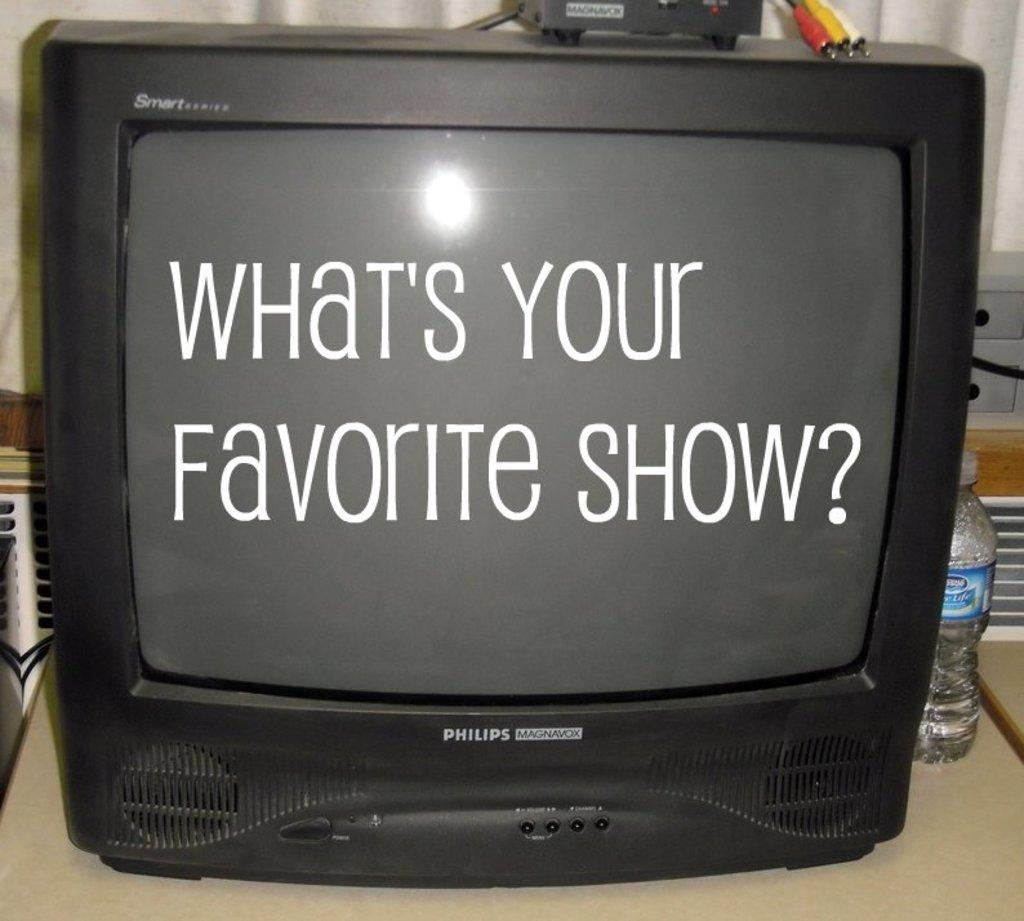<image>
Present a compact description of the photo's key features. black tube tv screen that reads whats your favorite show? and a bottle of water necxt to it 